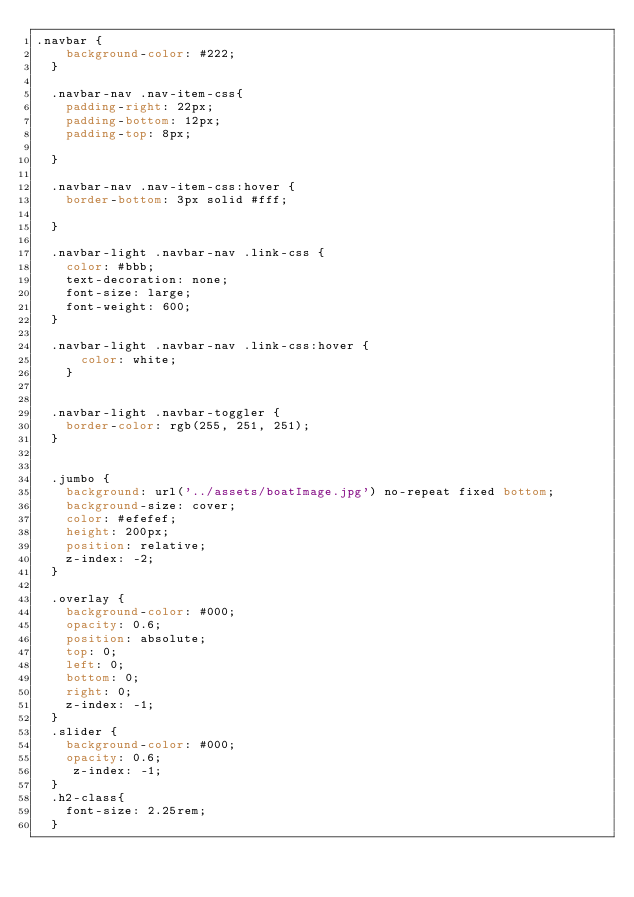Convert code to text. <code><loc_0><loc_0><loc_500><loc_500><_CSS_>.navbar {
    background-color: #222;
  }

  .navbar-nav .nav-item-css{
    padding-right: 22px;
    padding-bottom: 12px;
    padding-top: 8px;

  }

  .navbar-nav .nav-item-css:hover {
    border-bottom: 3px solid #fff;

  }

  .navbar-light .navbar-nav .link-css {
    color: #bbb;
    text-decoration: none;
    font-size: large;
    font-weight: 600;
  }

  .navbar-light .navbar-nav .link-css:hover {
      color: white;
    }
    
  
  .navbar-light .navbar-toggler {
    border-color: rgb(255, 251, 251);
  }


  .jumbo {
    background: url('../assets/boatImage.jpg') no-repeat fixed bottom;
    background-size: cover;
    color: #efefef;
    height: 200px;
    position: relative;
    z-index: -2;
  }

  .overlay {
    background-color: #000;
    opacity: 0.6;
    position: absolute;
    top: 0;
    left: 0;
    bottom: 0;
    right: 0;
    z-index: -1;
  }
  .slider {
    background-color: #000;
    opacity: 0.6;
     z-index: -1;
  }
  .h2-class{
    font-size: 2.25rem;
  }</code> 